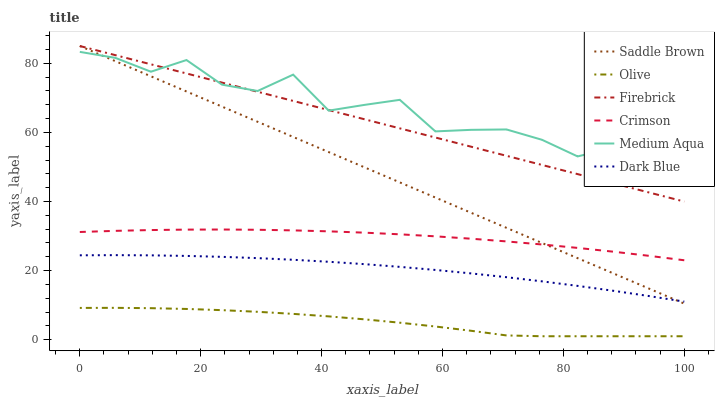Does Olive have the minimum area under the curve?
Answer yes or no. Yes. Does Medium Aqua have the maximum area under the curve?
Answer yes or no. Yes. Does Firebrick have the minimum area under the curve?
Answer yes or no. No. Does Firebrick have the maximum area under the curve?
Answer yes or no. No. Is Firebrick the smoothest?
Answer yes or no. Yes. Is Medium Aqua the roughest?
Answer yes or no. Yes. Is Crimson the smoothest?
Answer yes or no. No. Is Crimson the roughest?
Answer yes or no. No. Does Olive have the lowest value?
Answer yes or no. Yes. Does Firebrick have the lowest value?
Answer yes or no. No. Does Saddle Brown have the highest value?
Answer yes or no. Yes. Does Crimson have the highest value?
Answer yes or no. No. Is Crimson less than Firebrick?
Answer yes or no. Yes. Is Dark Blue greater than Olive?
Answer yes or no. Yes. Does Dark Blue intersect Saddle Brown?
Answer yes or no. Yes. Is Dark Blue less than Saddle Brown?
Answer yes or no. No. Is Dark Blue greater than Saddle Brown?
Answer yes or no. No. Does Crimson intersect Firebrick?
Answer yes or no. No. 